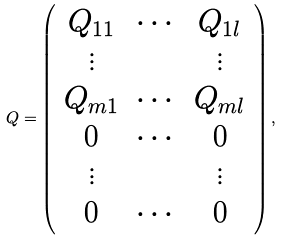<formula> <loc_0><loc_0><loc_500><loc_500>Q = \left ( \begin{array} { c c c } Q _ { 1 1 } & \cdots & Q _ { 1 l } \\ \vdots & & \vdots \\ Q _ { m 1 } & \cdots & Q _ { m l } \\ 0 & \cdots & 0 \\ \vdots & & \vdots \\ 0 & \cdots & 0 \end{array} \right ) ,</formula> 